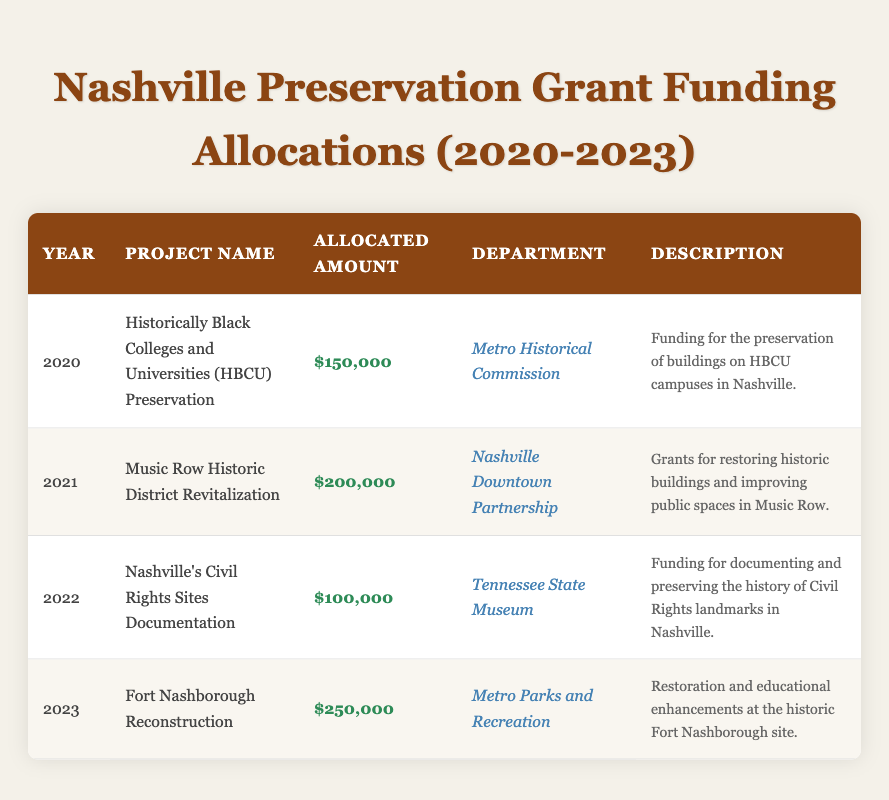What was the allocated amount for the "Fort Nashborough Reconstruction" project? The table lists the "Fort Nashborough Reconstruction" project under the year 2023 with an allocated amount of $250,000.
Answer: $250,000 Which department was responsible for the "Music Row Historic District Revitalization"? The table shows that the "Music Row Historic District Revitalization" project was allocated to the "Nashville Downtown Partnership."
Answer: Nashville Downtown Partnership How many projects received funding in 2021? There is only one project listed for the year 2021, which is the "Music Row Historic District Revitalization."
Answer: 1 What is the total allocated amount for all projects from 2020 to 2023? By adding the allocated amounts from each project: $150,000 (2020) + $200,000 (2021) + $100,000 (2022) + $250,000 (2023) = $700,000 total.
Answer: $700,000 Did any projects focus on Civil Rights history? The table indicates that there is one project focusing on Civil Rights history, which is "Nashville's Civil Rights Sites Documentation" in 2022.
Answer: Yes What was the average allocated amount across all years? To find the average, we sum the allocated amounts: $150,000 + $200,000 + $100,000 + $250,000 = $700,000. Then we divide by the number of projects (4), which gives us $700,000 / 4 = $175,000.
Answer: $175,000 Which project had the largest funding allocation and what year was it? The "Fort Nashborough Reconstruction" received the largest funding allocation of $250,000 in 2023.
Answer: Fort Nashborough Reconstruction, 2023 Was more funding allocated for projects in 2023 compared to 2021? In 2023, the project "Fort Nashborough Reconstruction" received $250,000, which is more than the $200,000 allocated for the "Music Row Historic District Revitalization" in 2021.
Answer: Yes How many different departments were involved in funding projects from 2020 to 2023? The table indicates three different departments: Metro Historical Commission, Nashville Downtown Partnership, and Tennessee State Museum for 2020, 2021, and 2022 respectively, along with Metro Parks and Recreation for 2023, resulting in four distinct departments.
Answer: 4 